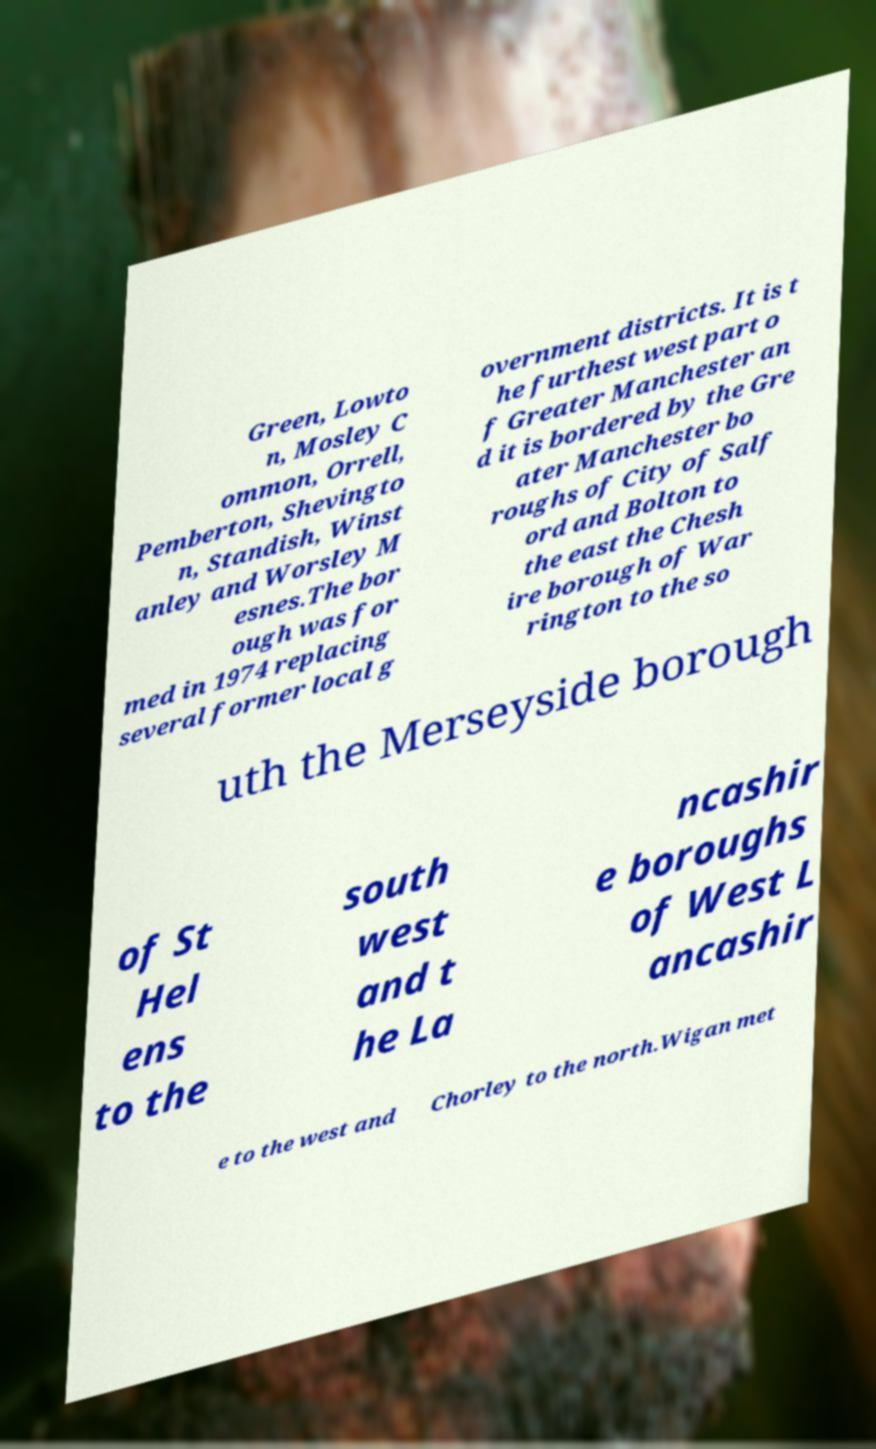Please read and relay the text visible in this image. What does it say? Green, Lowto n, Mosley C ommon, Orrell, Pemberton, Shevingto n, Standish, Winst anley and Worsley M esnes.The bor ough was for med in 1974 replacing several former local g overnment districts. It is t he furthest west part o f Greater Manchester an d it is bordered by the Gre ater Manchester bo roughs of City of Salf ord and Bolton to the east the Chesh ire borough of War rington to the so uth the Merseyside borough of St Hel ens to the south west and t he La ncashir e boroughs of West L ancashir e to the west and Chorley to the north.Wigan met 